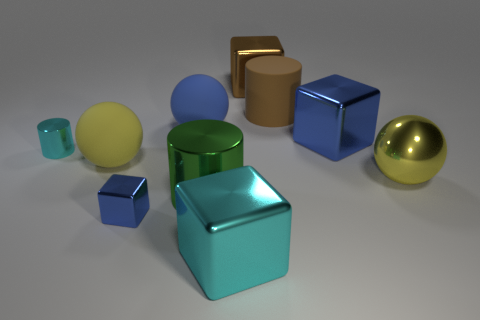Subtract all cubes. How many objects are left? 6 Subtract all large cyan objects. Subtract all small cyan rubber cylinders. How many objects are left? 9 Add 9 rubber cylinders. How many rubber cylinders are left? 10 Add 3 large matte objects. How many large matte objects exist? 6 Subtract 0 purple cubes. How many objects are left? 10 